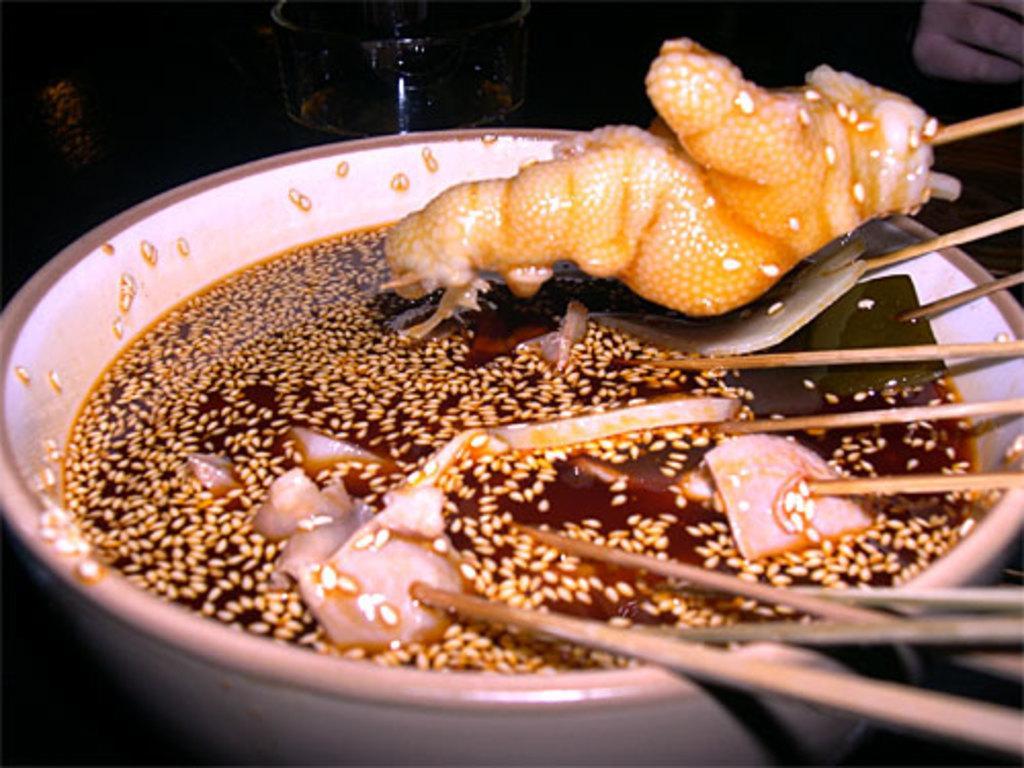Please provide a concise description of this image. In this image there are some food item and noodle sticks in a bowl, beside the bowl there is a glass with a drink and a person's hand. 